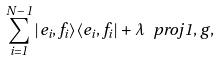<formula> <loc_0><loc_0><loc_500><loc_500>\sum _ { i = 1 } ^ { N - 1 } | e _ { i } , f _ { i } \rangle \langle e _ { i } , f _ { i } | + \lambda \ p r o j { 1 , g } ,</formula> 